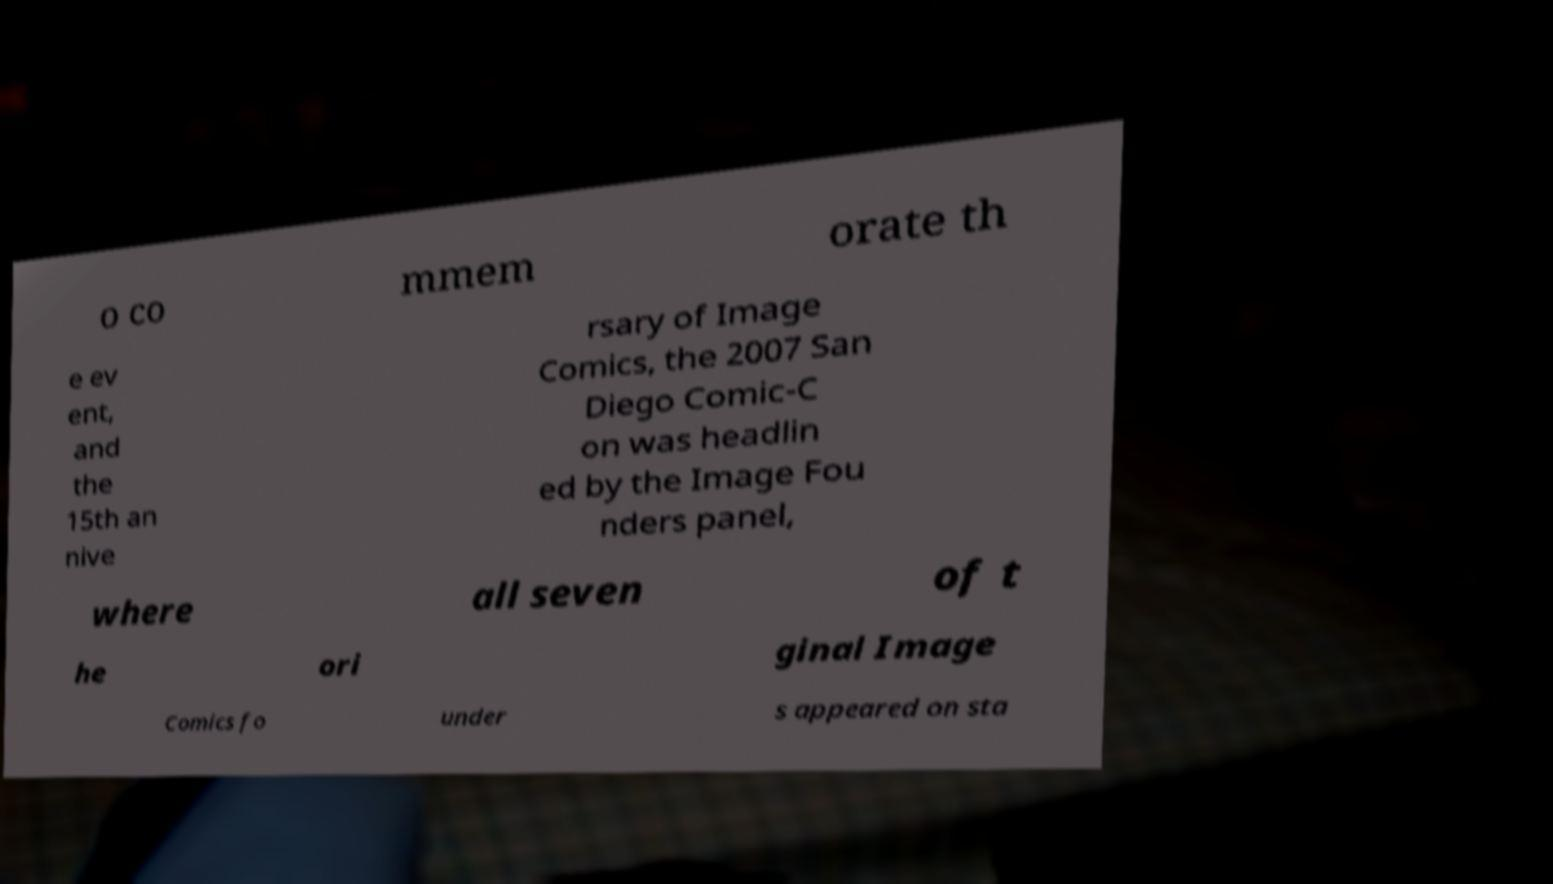Can you read and provide the text displayed in the image?This photo seems to have some interesting text. Can you extract and type it out for me? o co mmem orate th e ev ent, and the 15th an nive rsary of Image Comics, the 2007 San Diego Comic-C on was headlin ed by the Image Fou nders panel, where all seven of t he ori ginal Image Comics fo under s appeared on sta 